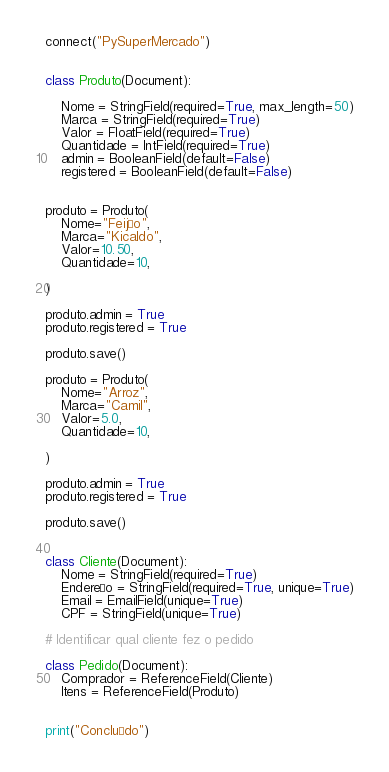Convert code to text. <code><loc_0><loc_0><loc_500><loc_500><_Python_>
connect("PySuperMercado")


class Produto(Document):

    Nome = StringField(required=True, max_length=50)
    Marca = StringField(required=True)
    Valor = FloatField(required=True)
    Quantidade = IntField(required=True)
    admin = BooleanField(default=False)
    registered = BooleanField(default=False)


produto = Produto(
    Nome="Feijão",
    Marca="Kicaldo",
    Valor=10.50,
    Quantidade=10,

)

produto.admin = True
produto.registered = True

produto.save()

produto = Produto(
    Nome="Arroz",
    Marca="Camil",
    Valor=5.0,
    Quantidade=10,

)

produto.admin = True
produto.registered = True

produto.save()


class Cliente(Document):
    Nome = StringField(required=True)
    Endereço = StringField(required=True, unique=True)
    Email = EmailField(unique=True)
    CPF = StringField(unique=True)

# Identificar qual cliente fez o pedido

class Pedido(Document):
    Comprador = ReferenceField(Cliente)
    Itens = ReferenceField(Produto)


print("Concluído")
</code> 